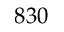<formula> <loc_0><loc_0><loc_500><loc_500>8 3 0</formula> 